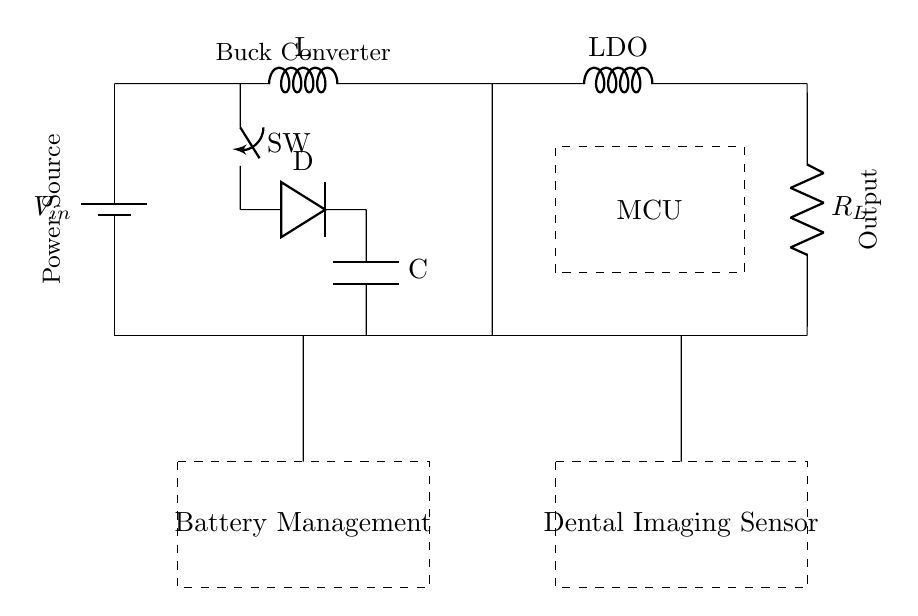What is the power source in this circuit? The power source in this circuit is labeled as V_in, located at the top left. It is represented by a battery symbol in the diagram.
Answer: V_in What type of converter is shown in this circuit? The diagram features a buck converter, which steps down voltage. This is indicated by the label next to the components in that section of the circuit.
Answer: Buck converter How many main sections are present in the circuit? The circuit consists of four main sections: Power Source, Buck Converter, Battery Management, and Dental Imaging Sensor, evident from the dashed boxes in the diagram.
Answer: Four What does LDO stand for in this context? LDO in this circuit stands for Low Dropout Regulator, indicated by the label near one of the components in the voltage regulation section of the diagram.
Answer: Low Dropout Regulator What is the purpose of the microcontroller in this circuit? The microcontroller (MCU) is responsible for processing and managing the operation of the circuit, positioned at the top right. While the specific functions aren't detailed in the diagram, its role is crucial for control and logic functions.
Answer: Control and manage What is the role of the \(R_L\) component in this circuit? The \(R_L\) component acts as a load resistor, which helps to regulate the current flowing through the circuit. This is evident as it connects to the output section with a designation that indicates a load.
Answer: Load resistor Which component connects the battery management to the power output? The connection between the battery management section and the output is made through the preservation of voltage, indicated by the short connection lines that directly lead upwards to the output line.
Answer: Short connection lines 